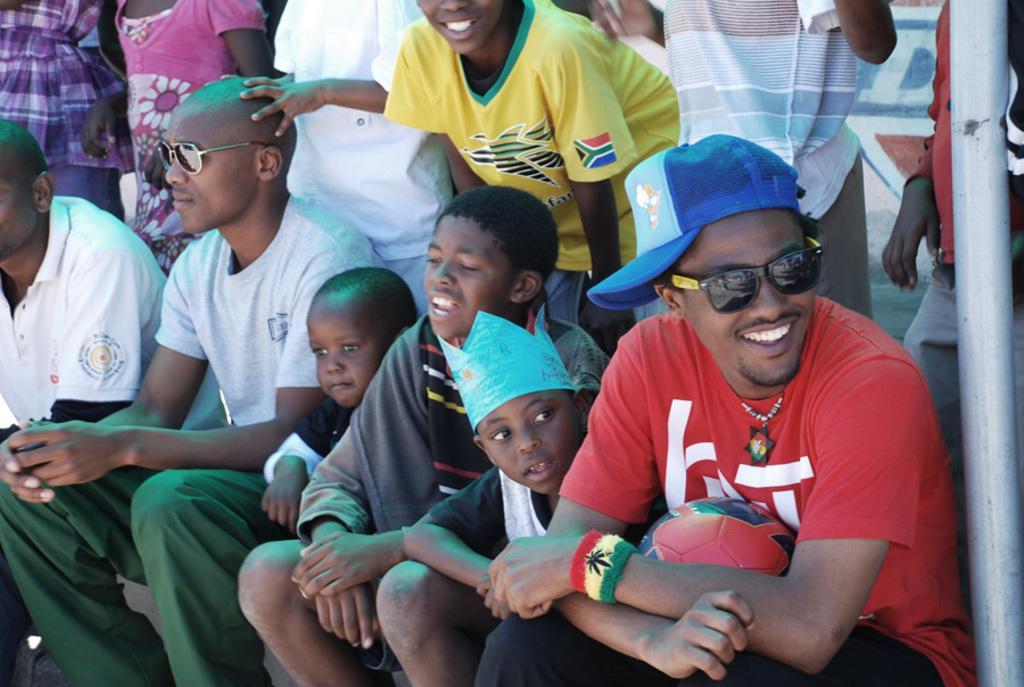Can you describe this image briefly? In this picture we can see a group of people, among them few people sitting and few people standing. Behind the people, it looks like a wall. On the right side of the image, there is a man with a ball, goggles and a cap and there is a pole. 